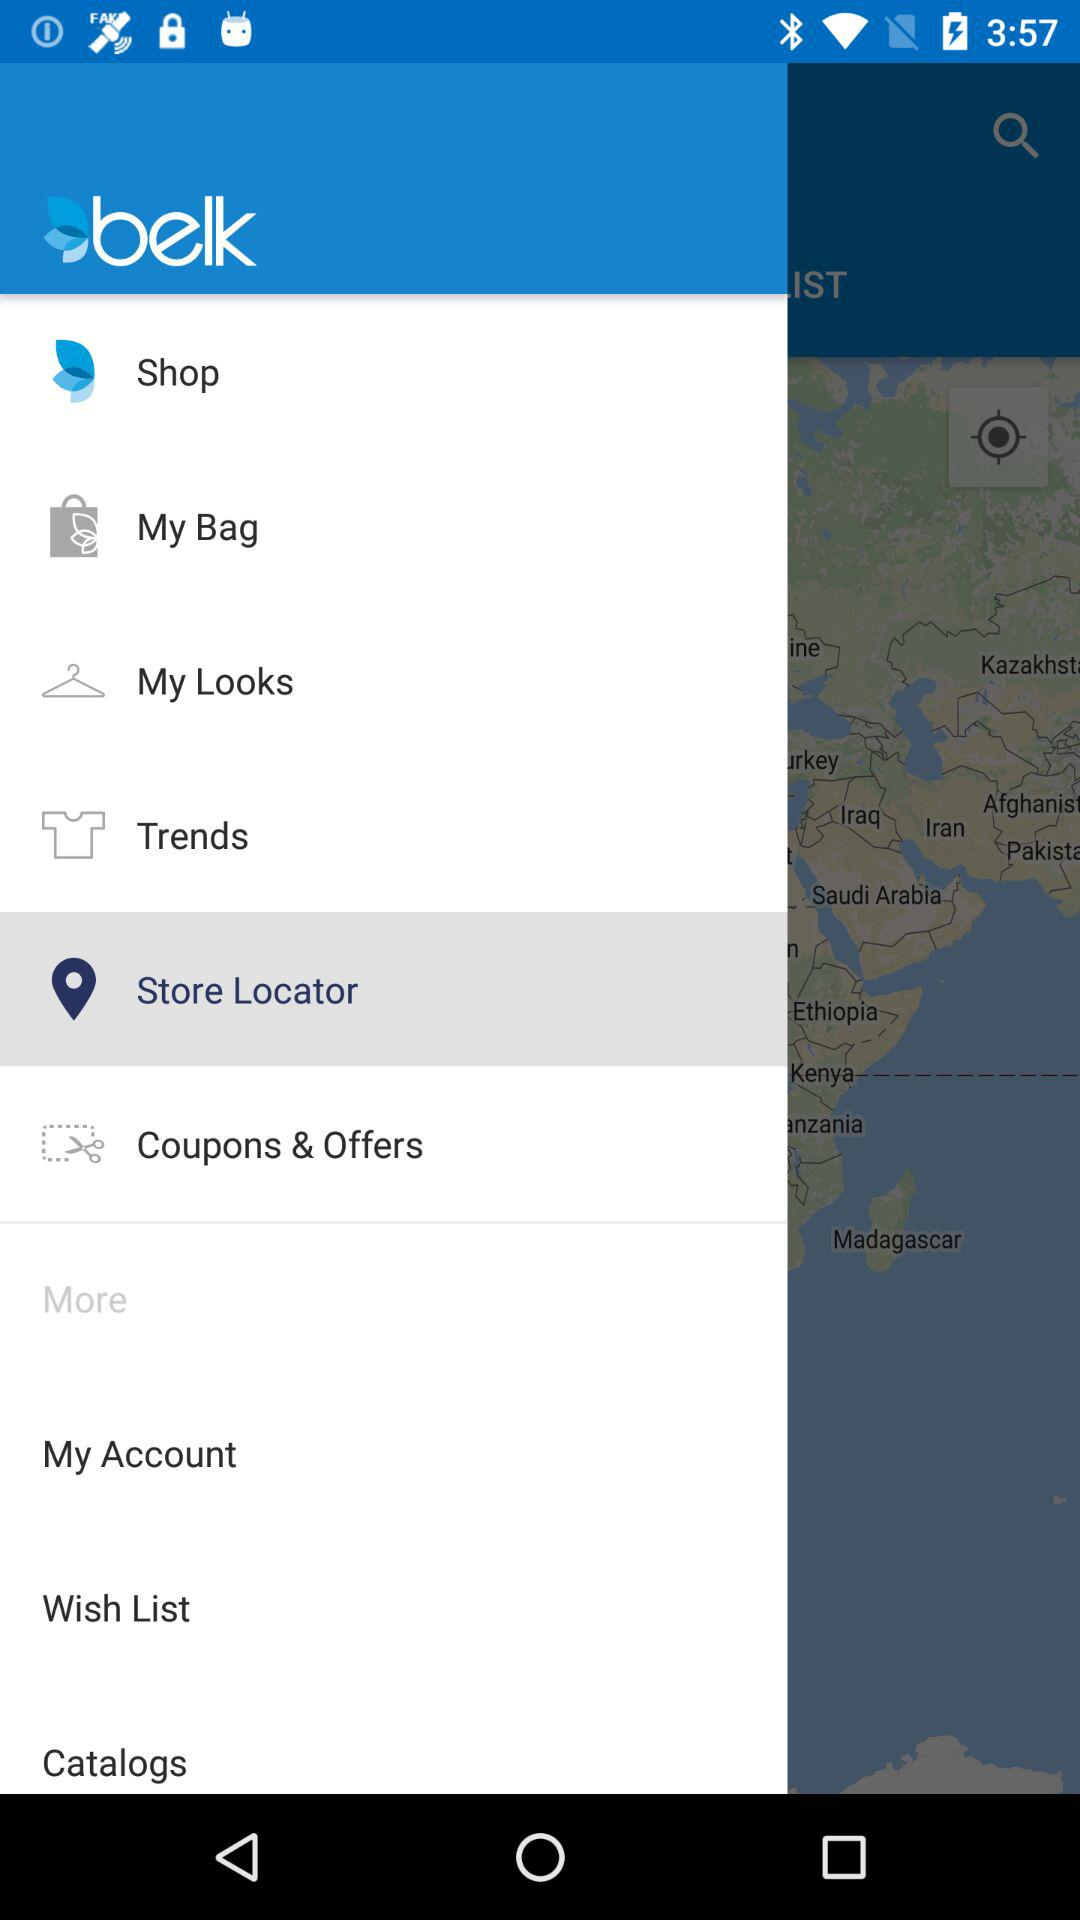What is the application name? The application name is "belk". 